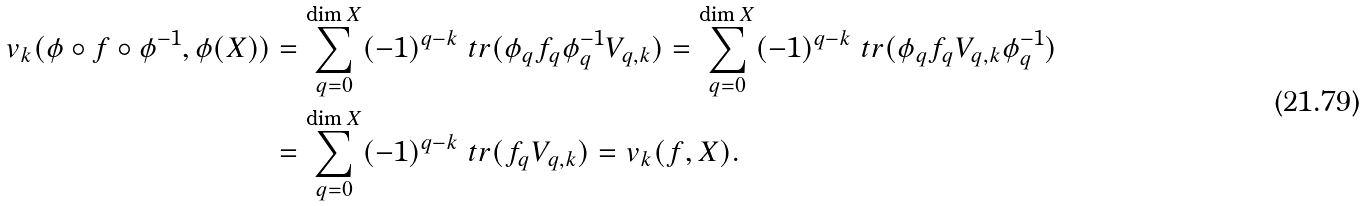<formula> <loc_0><loc_0><loc_500><loc_500>v _ { k } ( \phi \circ f \circ \phi ^ { - 1 } , \phi ( X ) ) & = \sum _ { q = 0 } ^ { \dim X } ( - 1 ) ^ { q - k } \ t r ( \phi _ { q } f _ { q } \phi ^ { - 1 } _ { q } V _ { q , k } ) = \sum _ { q = 0 } ^ { \dim X } ( - 1 ) ^ { q - k } \ t r ( \phi _ { q } f _ { q } V _ { q , k } \phi ^ { - 1 } _ { q } ) \\ & = \sum _ { q = 0 } ^ { \dim X } ( - 1 ) ^ { q - k } \ t r ( f _ { q } V _ { q , k } ) = v _ { k } ( f , X ) .</formula> 